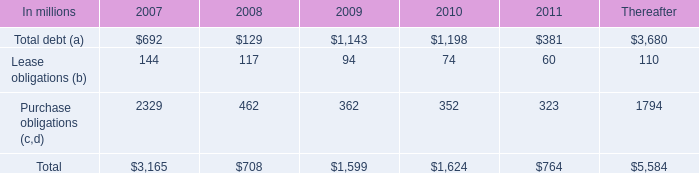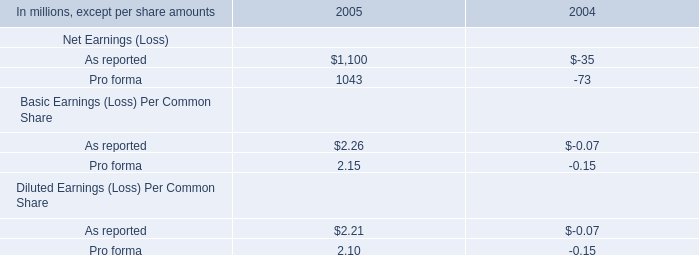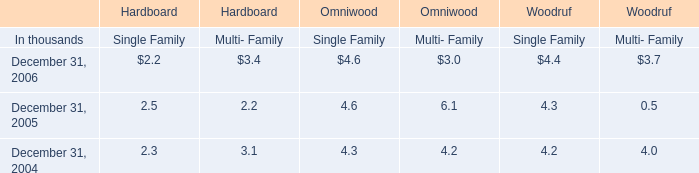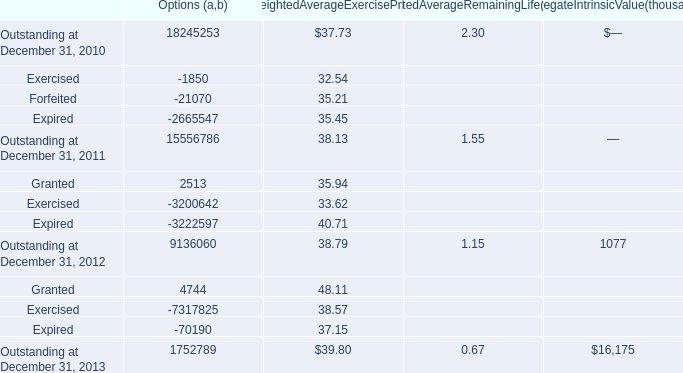In the year with largest amount of Outstanding at December 31, 2013, what's the sum of Exercised and Forfeited (in million) 
Computations: (-1850 - 21070)
Answer: -22920.0. 